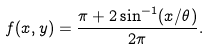Convert formula to latex. <formula><loc_0><loc_0><loc_500><loc_500>f ( x , y ) = \frac { \pi + 2 \sin ^ { - 1 } ( x / \theta ) } { 2 \pi } .</formula> 